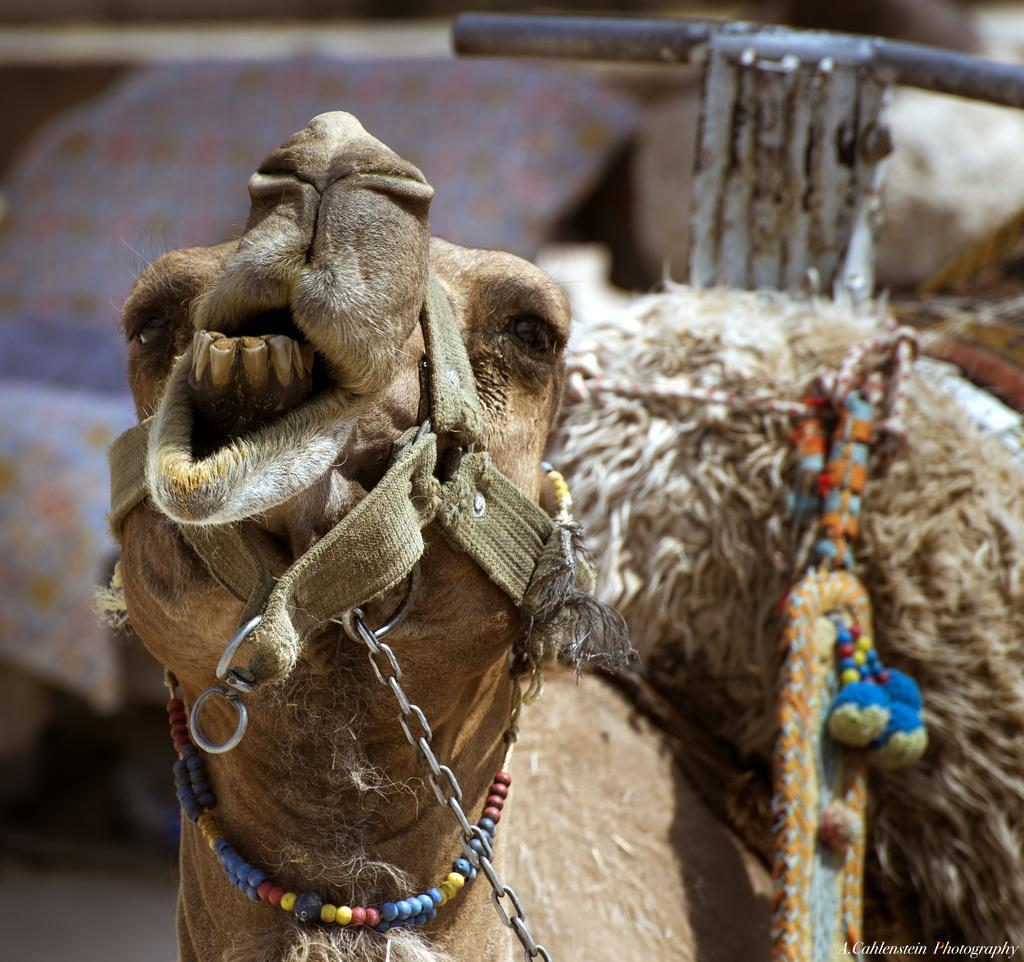What subject is depicted in the image? The image appears to depict the face of a camel. What type of chalk is being used to draw the camel's face in the image? There is no chalk present in the image, and the camel's face is not being drawn. 